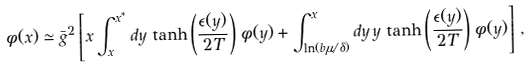Convert formula to latex. <formula><loc_0><loc_0><loc_500><loc_500>\phi ( x ) \simeq \bar { g } ^ { 2 } \left [ x \int _ { x } ^ { x ^ { * } } d y \, \tanh \left ( \frac { \epsilon ( y ) } { 2 T } \right ) \, \phi ( y ) + \int _ { \ln ( b \mu / \delta ) } ^ { x } d y \, y \, \tanh \left ( \frac { \epsilon ( y ) } { 2 T } \right ) \, \phi ( y ) \right ] \, ,</formula> 